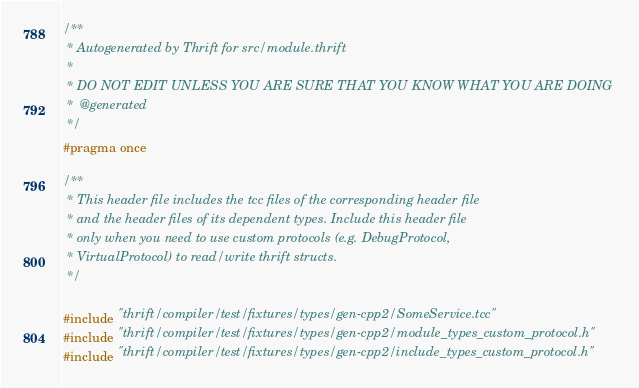<code> <loc_0><loc_0><loc_500><loc_500><_C_>/**
 * Autogenerated by Thrift for src/module.thrift
 *
 * DO NOT EDIT UNLESS YOU ARE SURE THAT YOU KNOW WHAT YOU ARE DOING
 *  @generated
 */
#pragma once

/**
 * This header file includes the tcc files of the corresponding header file
 * and the header files of its dependent types. Include this header file
 * only when you need to use custom protocols (e.g. DebugProtocol,
 * VirtualProtocol) to read/write thrift structs.
 */

#include "thrift/compiler/test/fixtures/types/gen-cpp2/SomeService.tcc"
#include "thrift/compiler/test/fixtures/types/gen-cpp2/module_types_custom_protocol.h"
#include "thrift/compiler/test/fixtures/types/gen-cpp2/include_types_custom_protocol.h"
</code> 